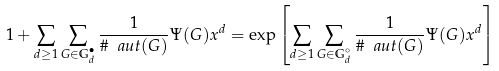<formula> <loc_0><loc_0><loc_500><loc_500>1 + \sum _ { d \geq 1 } \sum _ { G \in \mathbb { G } ^ { \bullet } _ { d } } \frac { 1 } { \# { \ a u t } ( G ) } \Psi ( G ) x ^ { d } = \exp \left [ \sum _ { d \geq 1 } \sum _ { G \in \mathbb { G } ^ { \circ } _ { d } } \frac { 1 } { \# { \ a u t } ( G ) } \Psi ( G ) x ^ { d } \right ]</formula> 